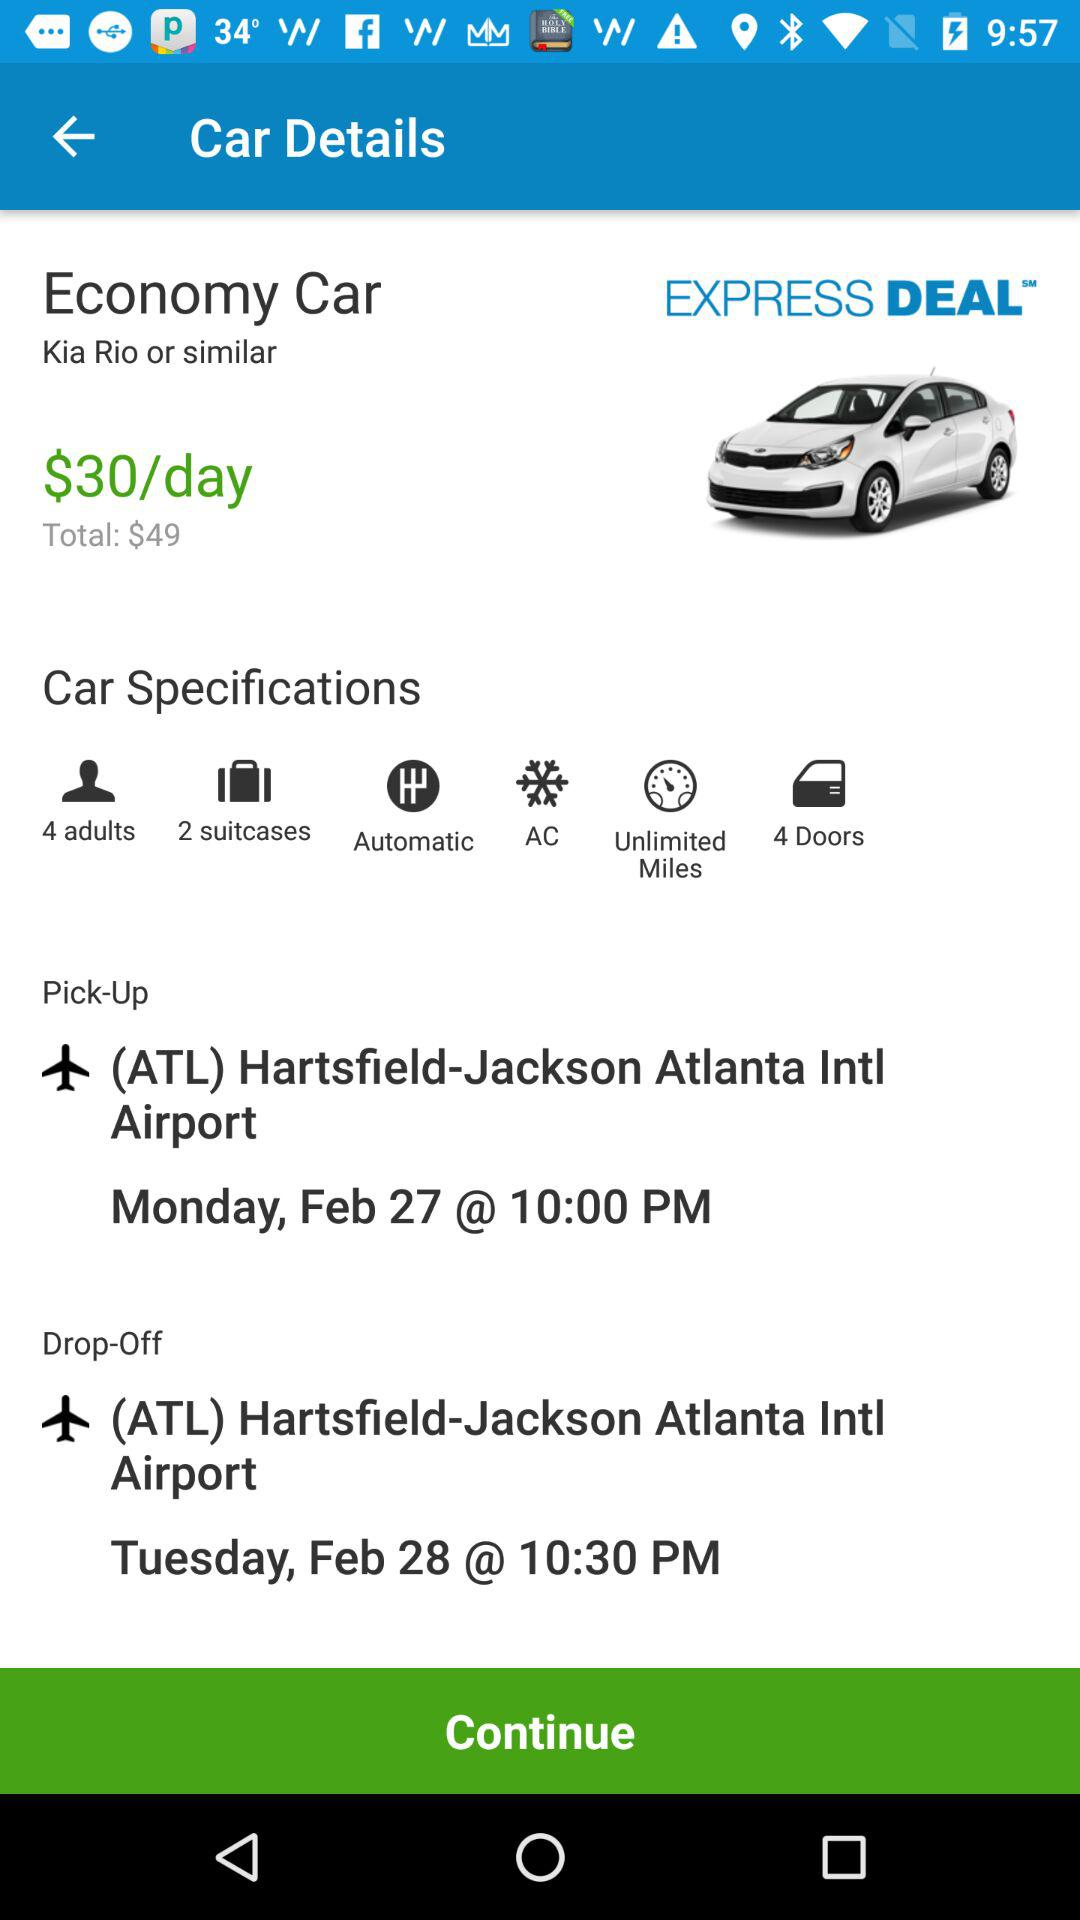What is the pick-up date and time? The pick-up date is Monday, February 27; the time is 10 p.m. 